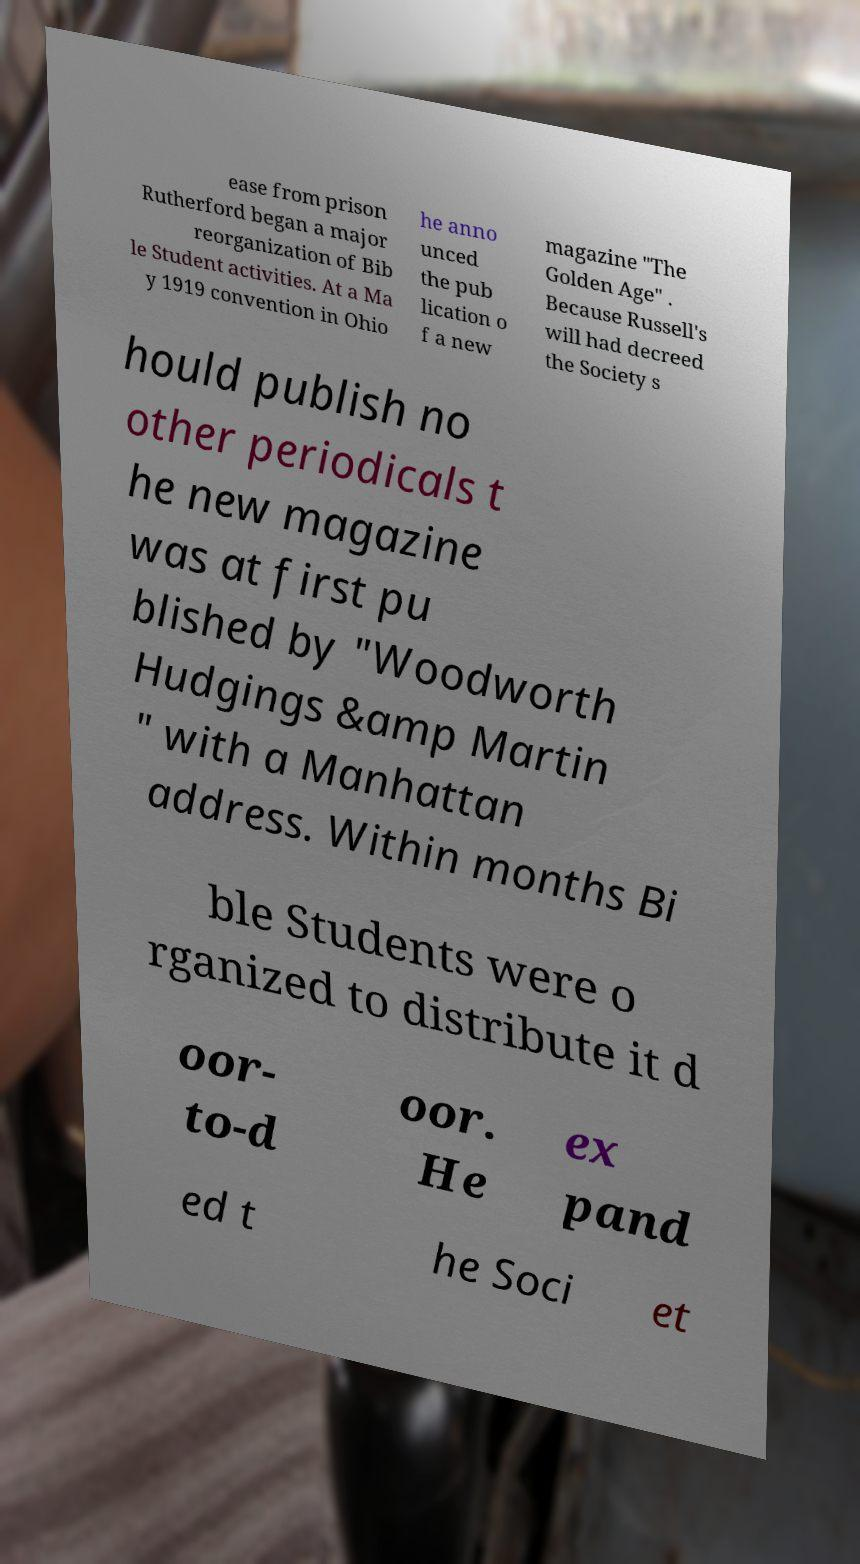I need the written content from this picture converted into text. Can you do that? ease from prison Rutherford began a major reorganization of Bib le Student activities. At a Ma y 1919 convention in Ohio he anno unced the pub lication o f a new magazine "The Golden Age" . Because Russell's will had decreed the Society s hould publish no other periodicals t he new magazine was at first pu blished by "Woodworth Hudgings &amp Martin " with a Manhattan address. Within months Bi ble Students were o rganized to distribute it d oor- to-d oor. He ex pand ed t he Soci et 